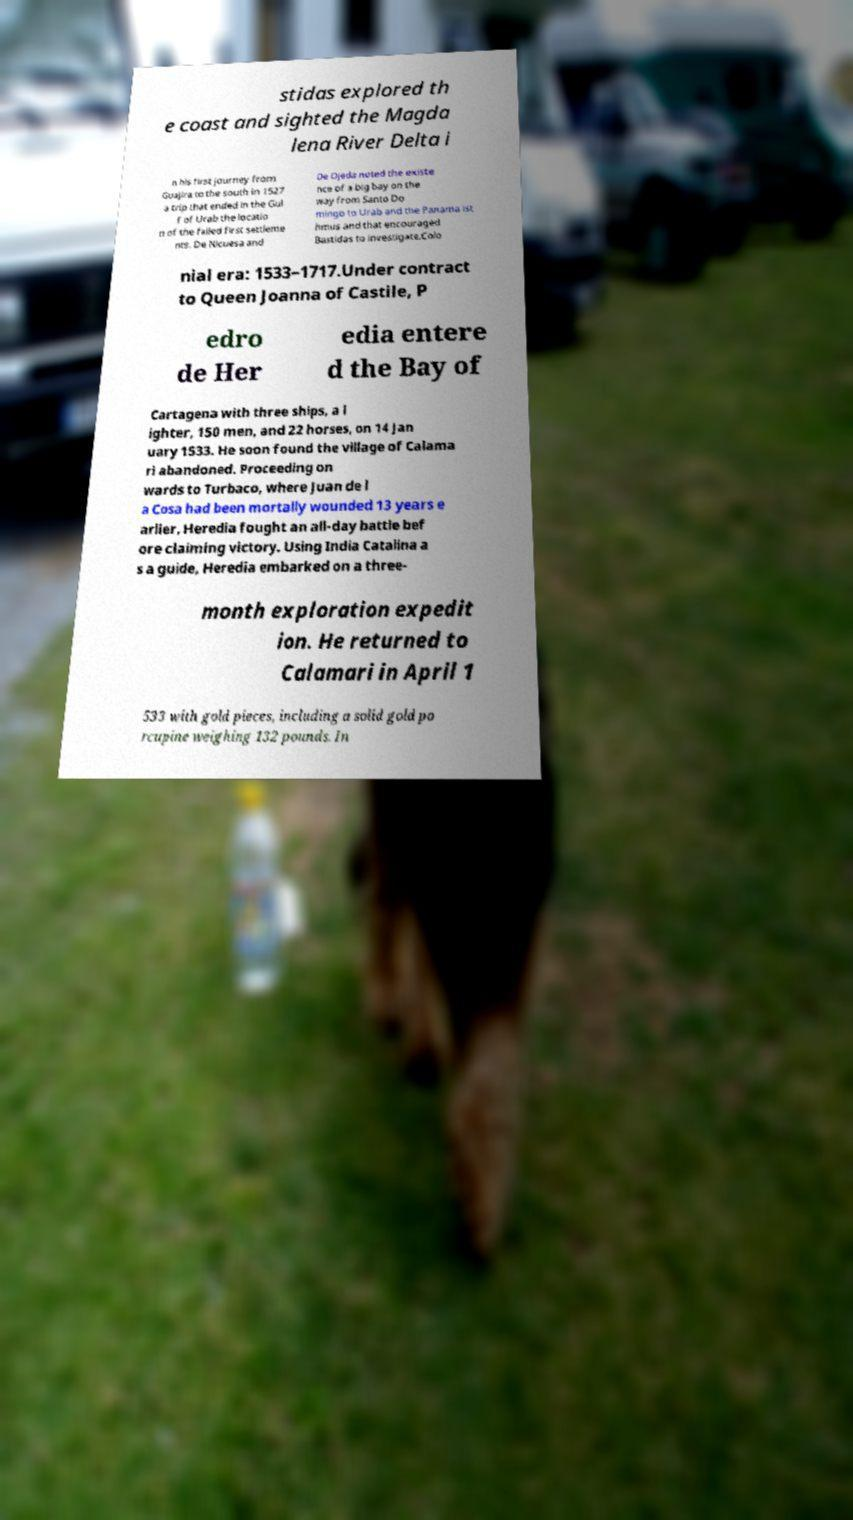I need the written content from this picture converted into text. Can you do that? stidas explored th e coast and sighted the Magda lena River Delta i n his first journey from Guajira to the south in 1527 a trip that ended in the Gul f of Urab the locatio n of the failed first settleme nts. De Nicuesa and De Ojeda noted the existe nce of a big bay on the way from Santo Do mingo to Urab and the Panama ist hmus and that encouraged Bastidas to investigate.Colo nial era: 1533–1717.Under contract to Queen Joanna of Castile, P edro de Her edia entere d the Bay of Cartagena with three ships, a l ighter, 150 men, and 22 horses, on 14 Jan uary 1533. He soon found the village of Calama ri abandoned. Proceeding on wards to Turbaco, where Juan de l a Cosa had been mortally wounded 13 years e arlier, Heredia fought an all-day battle bef ore claiming victory. Using India Catalina a s a guide, Heredia embarked on a three- month exploration expedit ion. He returned to Calamari in April 1 533 with gold pieces, including a solid gold po rcupine weighing 132 pounds. In 